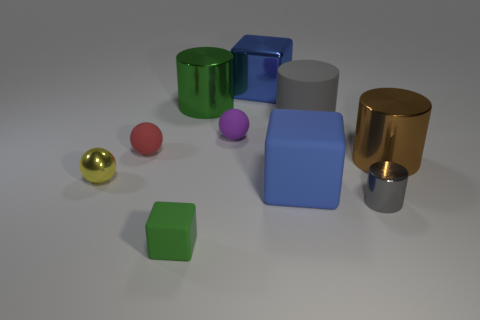What number of gray cylinders are the same size as the green matte cube?
Your answer should be very brief. 1. Is the number of big gray cylinders behind the large green object greater than the number of tiny metal cylinders that are behind the big gray matte cylinder?
Your answer should be compact. No. There is a shiny cylinder on the left side of the tiny sphere right of the red ball; what color is it?
Give a very brief answer. Green. Is the small green cube made of the same material as the yellow object?
Make the answer very short. No. Are there any tiny yellow things that have the same shape as the small purple matte object?
Provide a short and direct response. Yes. Does the big metallic cylinder that is behind the brown cylinder have the same color as the tiny block?
Keep it short and to the point. Yes. There is a gray cylinder that is behind the large brown cylinder; is it the same size as the gray cylinder in front of the small yellow object?
Your answer should be very brief. No. There is a purple sphere that is the same material as the red sphere; what size is it?
Offer a very short reply. Small. What number of objects are both behind the big gray cylinder and in front of the blue shiny block?
Keep it short and to the point. 1. How many things are large shiny things or blue objects in front of the blue shiny block?
Ensure brevity in your answer.  4. 